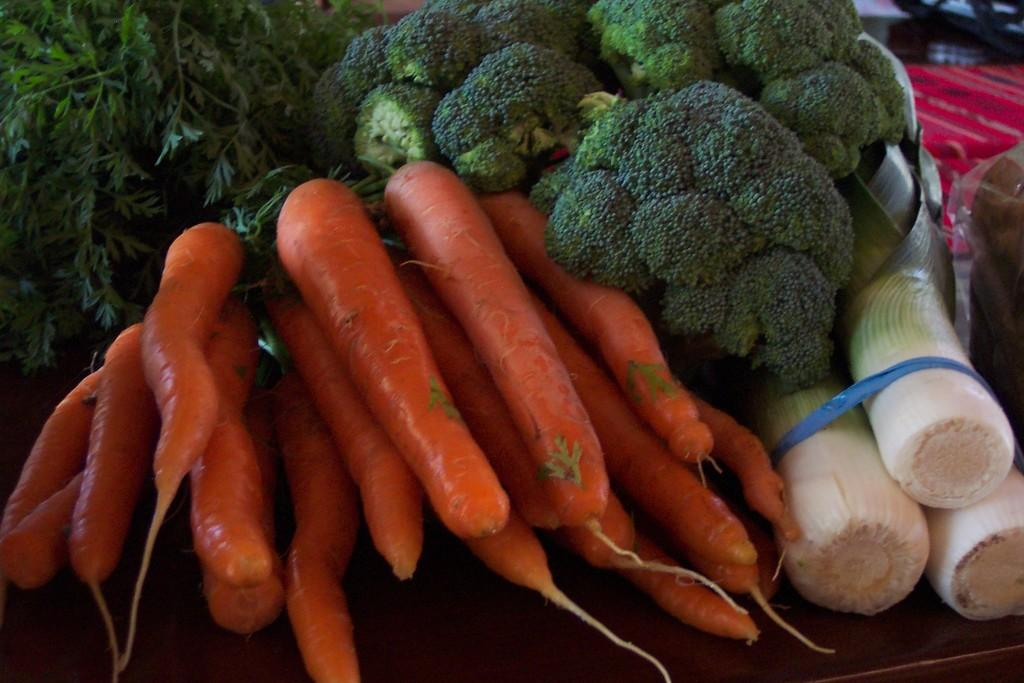What type of vegetable can be seen on the left side of the image? There are carrots on the left side of the image. What other type of vegetable is present in the image? There are leaves of coriander in the image. How many stars can be seen in the image? There are no stars present in the image. What type of utensil is used for brushing teeth in the image? There is no toothbrush or any reference to brushing teeth in the image. 